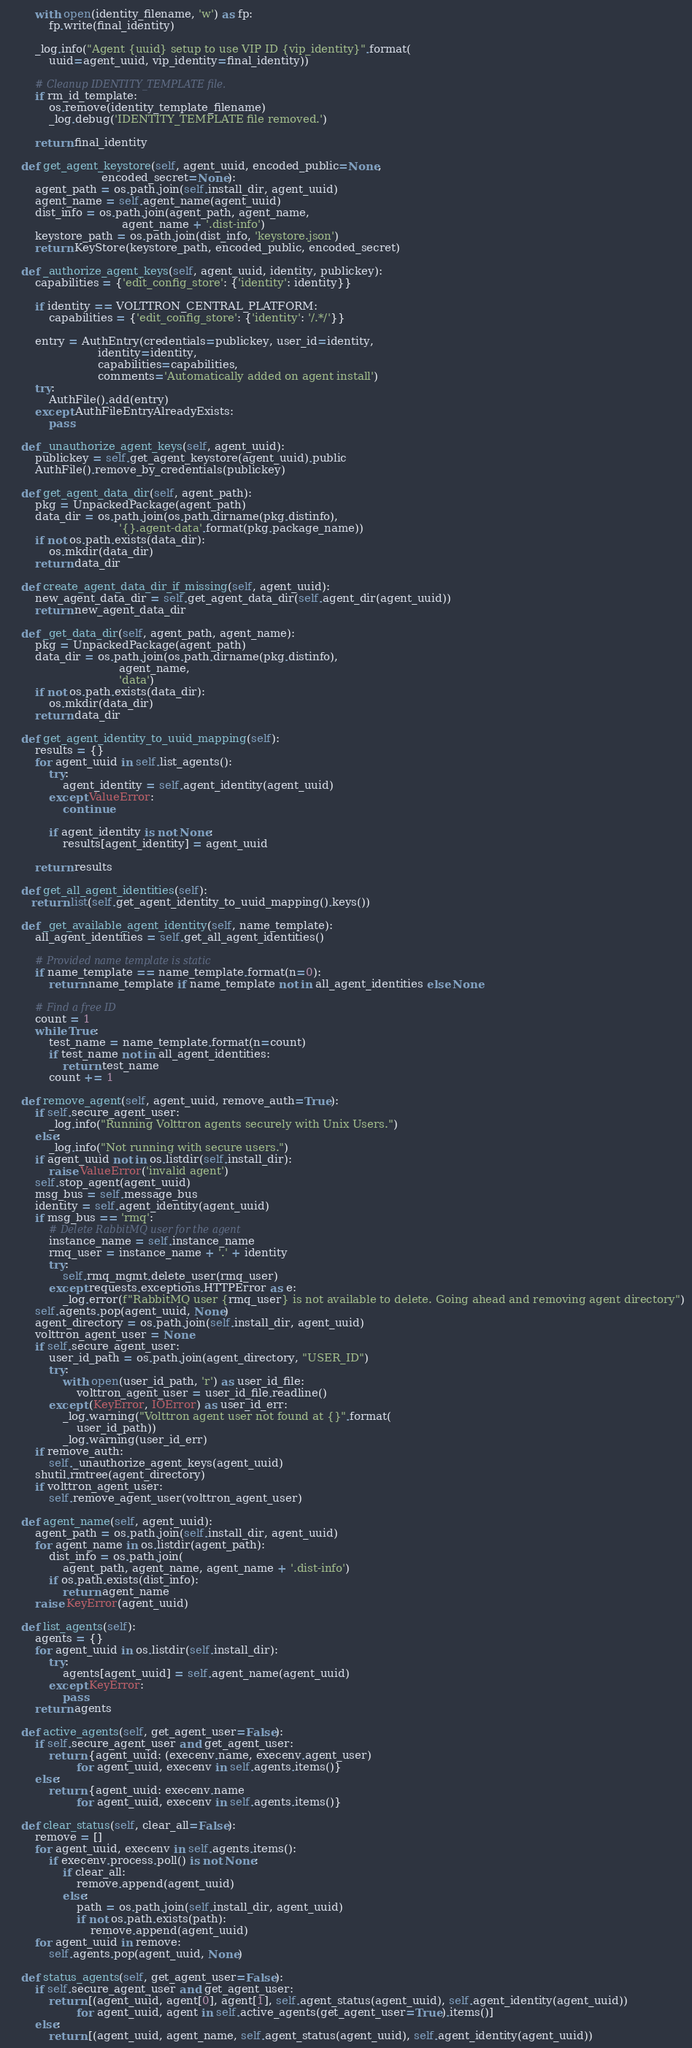Convert code to text. <code><loc_0><loc_0><loc_500><loc_500><_Python_>        with open(identity_filename, 'w') as fp:
            fp.write(final_identity)

        _log.info("Agent {uuid} setup to use VIP ID {vip_identity}".format(
            uuid=agent_uuid, vip_identity=final_identity))

        # Cleanup IDENTITY_TEMPLATE file.
        if rm_id_template:
            os.remove(identity_template_filename)
            _log.debug('IDENTITY_TEMPLATE file removed.')

        return final_identity

    def get_agent_keystore(self, agent_uuid, encoded_public=None,
                           encoded_secret=None):
        agent_path = os.path.join(self.install_dir, agent_uuid)
        agent_name = self.agent_name(agent_uuid)
        dist_info = os.path.join(agent_path, agent_name,
                                 agent_name + '.dist-info')
        keystore_path = os.path.join(dist_info, 'keystore.json')
        return KeyStore(keystore_path, encoded_public, encoded_secret)

    def _authorize_agent_keys(self, agent_uuid, identity, publickey):
        capabilities = {'edit_config_store': {'identity': identity}}

        if identity == VOLTTRON_CENTRAL_PLATFORM:
            capabilities = {'edit_config_store': {'identity': '/.*/'}}

        entry = AuthEntry(credentials=publickey, user_id=identity,
                          identity=identity,
                          capabilities=capabilities,
                          comments='Automatically added on agent install')
        try:
            AuthFile().add(entry)
        except AuthFileEntryAlreadyExists:
            pass

    def _unauthorize_agent_keys(self, agent_uuid):
        publickey = self.get_agent_keystore(agent_uuid).public
        AuthFile().remove_by_credentials(publickey)

    def get_agent_data_dir(self, agent_path):
        pkg = UnpackedPackage(agent_path)
        data_dir = os.path.join(os.path.dirname(pkg.distinfo),
                                '{}.agent-data'.format(pkg.package_name))
        if not os.path.exists(data_dir):
            os.mkdir(data_dir)
        return data_dir

    def create_agent_data_dir_if_missing(self, agent_uuid):
        new_agent_data_dir = self.get_agent_data_dir(self.agent_dir(agent_uuid))
        return new_agent_data_dir

    def _get_data_dir(self, agent_path, agent_name):
        pkg = UnpackedPackage(agent_path)
        data_dir = os.path.join(os.path.dirname(pkg.distinfo),
                                agent_name,
                                'data')
        if not os.path.exists(data_dir):
            os.mkdir(data_dir)
        return data_dir

    def get_agent_identity_to_uuid_mapping(self):
        results = {}
        for agent_uuid in self.list_agents():
            try:
                agent_identity = self.agent_identity(agent_uuid)
            except ValueError:
                continue

            if agent_identity is not None:
                results[agent_identity] = agent_uuid

        return results

    def get_all_agent_identities(self):
       return list(self.get_agent_identity_to_uuid_mapping().keys())

    def _get_available_agent_identity(self, name_template):
        all_agent_identities = self.get_all_agent_identities()

        # Provided name template is static
        if name_template == name_template.format(n=0):
            return name_template if name_template not in all_agent_identities else None

        # Find a free ID
        count = 1
        while True:
            test_name = name_template.format(n=count)
            if test_name not in all_agent_identities:
                return test_name
            count += 1

    def remove_agent(self, agent_uuid, remove_auth=True):
        if self.secure_agent_user:
            _log.info("Running Volttron agents securely with Unix Users.")
        else:
            _log.info("Not running with secure users.")
        if agent_uuid not in os.listdir(self.install_dir):
            raise ValueError('invalid agent')
        self.stop_agent(agent_uuid)
        msg_bus = self.message_bus
        identity = self.agent_identity(agent_uuid)
        if msg_bus == 'rmq':
            # Delete RabbitMQ user for the agent
            instance_name = self.instance_name
            rmq_user = instance_name + '.' + identity
            try:
                self.rmq_mgmt.delete_user(rmq_user)
            except requests.exceptions.HTTPError as e:
                _log.error(f"RabbitMQ user {rmq_user} is not available to delete. Going ahead and removing agent directory")
        self.agents.pop(agent_uuid, None)
        agent_directory = os.path.join(self.install_dir, agent_uuid)
        volttron_agent_user = None
        if self.secure_agent_user:
            user_id_path = os.path.join(agent_directory, "USER_ID")
            try:
                with open(user_id_path, 'r') as user_id_file:
                    volttron_agent_user = user_id_file.readline()
            except (KeyError, IOError) as user_id_err:
                _log.warning("Volttron agent user not found at {}".format(
                    user_id_path))
                _log.warning(user_id_err)
        if remove_auth:
            self._unauthorize_agent_keys(agent_uuid)
        shutil.rmtree(agent_directory)
        if volttron_agent_user:
            self.remove_agent_user(volttron_agent_user)

    def agent_name(self, agent_uuid):
        agent_path = os.path.join(self.install_dir, agent_uuid)
        for agent_name in os.listdir(agent_path):
            dist_info = os.path.join(
                agent_path, agent_name, agent_name + '.dist-info')
            if os.path.exists(dist_info):
                return agent_name
        raise KeyError(agent_uuid)

    def list_agents(self):
        agents = {}
        for agent_uuid in os.listdir(self.install_dir):
            try:
                agents[agent_uuid] = self.agent_name(agent_uuid)
            except KeyError:
                pass
        return agents

    def active_agents(self, get_agent_user=False):
        if self.secure_agent_user and get_agent_user:
            return {agent_uuid: (execenv.name, execenv.agent_user)
                    for agent_uuid, execenv in self.agents.items()}
        else:
            return {agent_uuid: execenv.name
                    for agent_uuid, execenv in self.agents.items()}

    def clear_status(self, clear_all=False):
        remove = []
        for agent_uuid, execenv in self.agents.items():
            if execenv.process.poll() is not None:
                if clear_all:
                    remove.append(agent_uuid)
                else:
                    path = os.path.join(self.install_dir, agent_uuid)
                    if not os.path.exists(path):
                        remove.append(agent_uuid)
        for agent_uuid in remove:
            self.agents.pop(agent_uuid, None)

    def status_agents(self, get_agent_user=False):
        if self.secure_agent_user and get_agent_user:
            return [(agent_uuid, agent[0], agent[1], self.agent_status(agent_uuid), self.agent_identity(agent_uuid))
                    for agent_uuid, agent in self.active_agents(get_agent_user=True).items()]
        else:
            return [(agent_uuid, agent_name, self.agent_status(agent_uuid), self.agent_identity(agent_uuid))</code> 